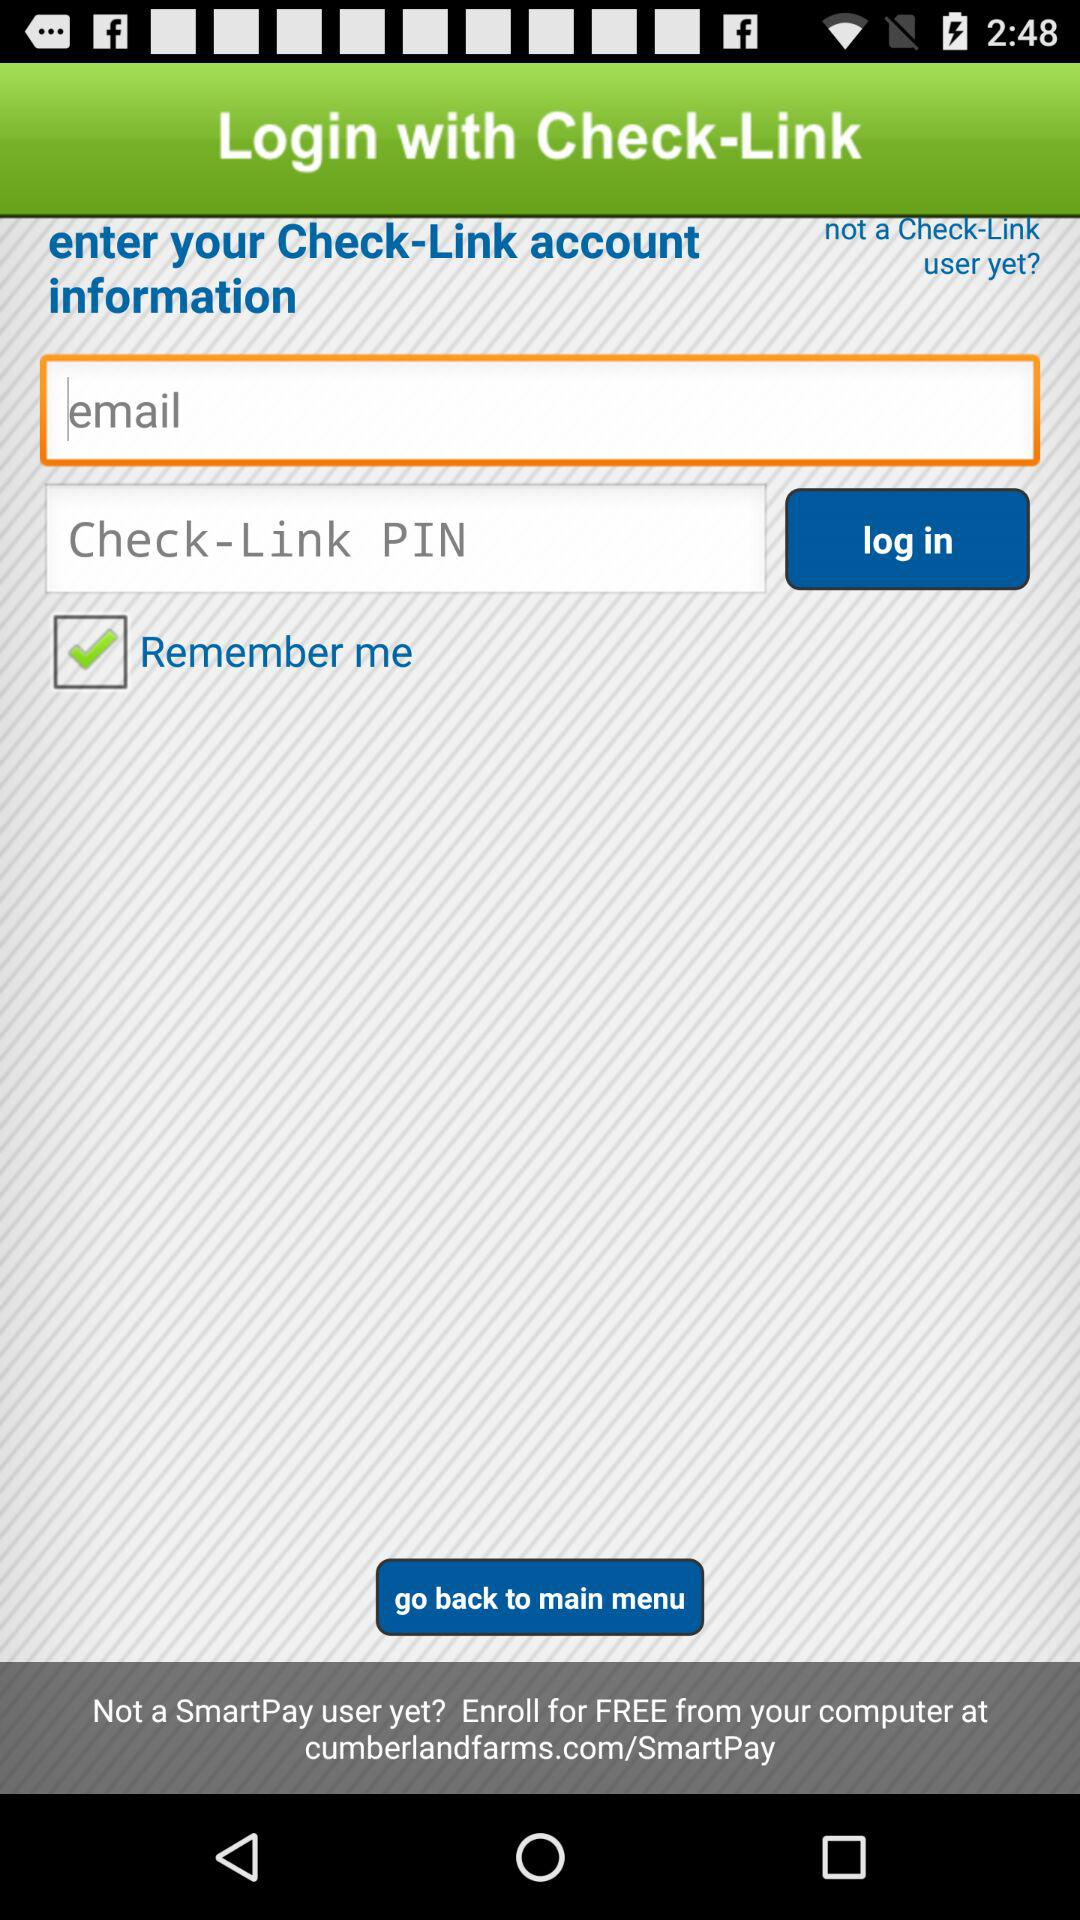How can we log in? You can log in with "Check-Link". 